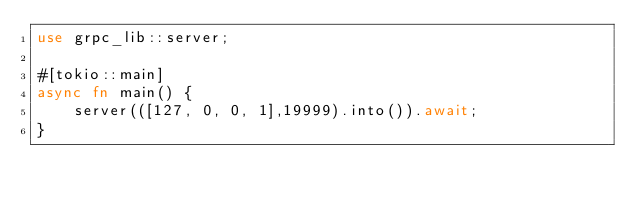<code> <loc_0><loc_0><loc_500><loc_500><_Rust_>use grpc_lib::server;

#[tokio::main]
async fn main() {
    server(([127, 0, 0, 1],19999).into()).await;
}

</code> 